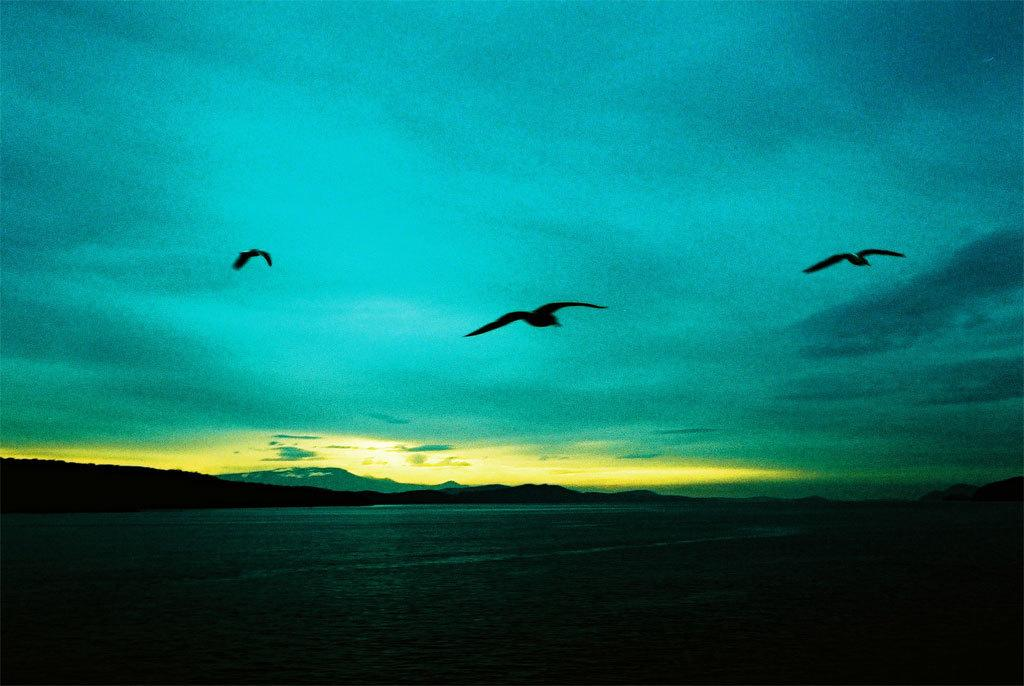What is located in front of the image? There is water in front of the image. What can be seen in the center of the image? There are 3 birds in the center of the image. What is visible in the background of the image? The sky is visible in the background of the image. How would you describe the lighting in the image? The image appears to be a bit dark. What type of insurance policy do the birds in the image have? There is no information about insurance policies for the birds in the image. How many cats are visible in the image? There are no cats present in the image; it features 3 birds. 